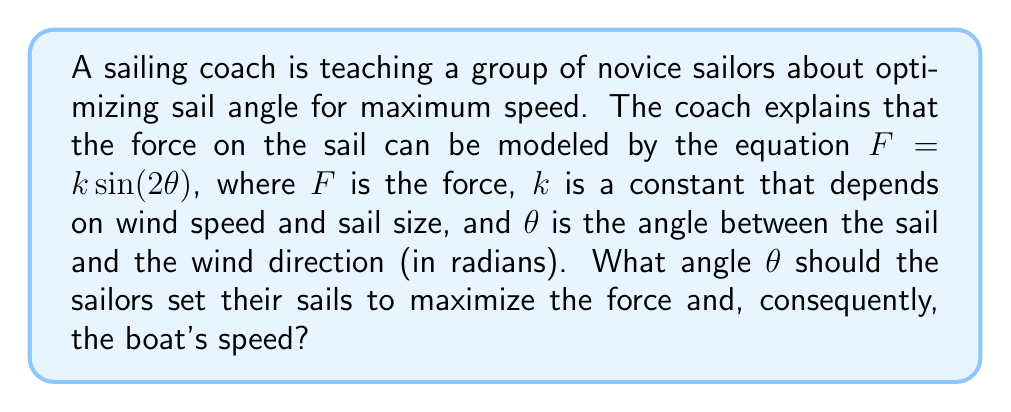Teach me how to tackle this problem. To find the optimal sail angle, we need to maximize the force function $F = k \sin(2\theta)$. Since $k$ is a constant, we can focus on maximizing $\sin(2\theta)$.

Step 1: Recall that the maximum value of sine is 1, which occurs when its argument is $\frac{\pi}{2}$ (or 90 degrees).

Step 2: Set up the equation:
$$2\theta = \frac{\pi}{2}$$

Step 3: Solve for $\theta$:
$$\theta = \frac{\pi}{4}$$

Step 4: Convert radians to degrees:
$$\theta = \frac{\pi}{4} \cdot \frac{180^\circ}{\pi} = 45^\circ$$

Step 5: Verify the result:
The sine function has a period of $2\pi$, so $\sin(2\theta)$ has a period of $\pi$. This means the function will reach its maximum twice in the interval $[0, \pi]$, at $\frac{\pi}{4}$ and $\frac{3\pi}{4}$. However, in the context of sailing, we're interested in the smaller angle.

[asy]
import graph;
size(200,150);
real f(real x) {return sin(2x);}
draw(graph(f,0,pi),blue);
draw((0,0)--(pi,0),arrow=Arrow);
draw((0,-1)--(0,1),arrow=Arrow);
label("$\theta$",(pi,0),S);
label("$F$",(0,1),W);
dot((pi/4,1));
label("$(\frac{\pi}{4},1)$",(pi/4,1),NE);
[/asy]

The graph shows that the maximum occurs at $\frac{\pi}{4}$ (45°) in the interval $[0, \frac{\pi}{2}]$, which is the relevant range for sail angles.
Answer: The optimal sail angle for maximum speed is $\frac{\pi}{4}$ radians or 45 degrees. 